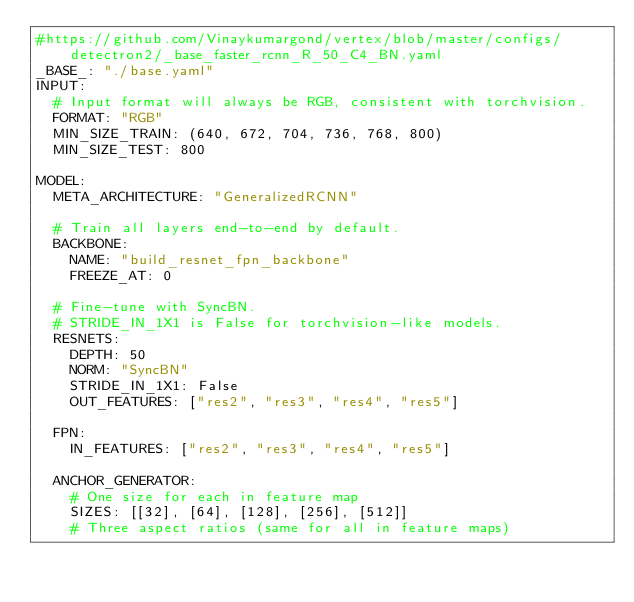Convert code to text. <code><loc_0><loc_0><loc_500><loc_500><_YAML_>#https://github.com/Vinaykumargond/vertex/blob/master/configs/detectron2/_base_faster_rcnn_R_50_C4_BN.yaml
_BASE_: "./base.yaml"
INPUT:
  # Input format will always be RGB, consistent with torchvision.
  FORMAT: "RGB"
  MIN_SIZE_TRAIN: (640, 672, 704, 736, 768, 800)
  MIN_SIZE_TEST: 800

MODEL:
  META_ARCHITECTURE: "GeneralizedRCNN"

  # Train all layers end-to-end by default.
  BACKBONE:
    NAME: "build_resnet_fpn_backbone"
    FREEZE_AT: 0

  # Fine-tune with SyncBN.
  # STRIDE_IN_1X1 is False for torchvision-like models.
  RESNETS:
    DEPTH: 50
    NORM: "SyncBN"
    STRIDE_IN_1X1: False
    OUT_FEATURES: ["res2", "res3", "res4", "res5"]

  FPN:
    IN_FEATURES: ["res2", "res3", "res4", "res5"]

  ANCHOR_GENERATOR:
    # One size for each in feature map
    SIZES: [[32], [64], [128], [256], [512]]
    # Three aspect ratios (same for all in feature maps)</code> 